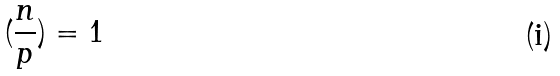Convert formula to latex. <formula><loc_0><loc_0><loc_500><loc_500>( \frac { n } { p } ) = 1</formula> 